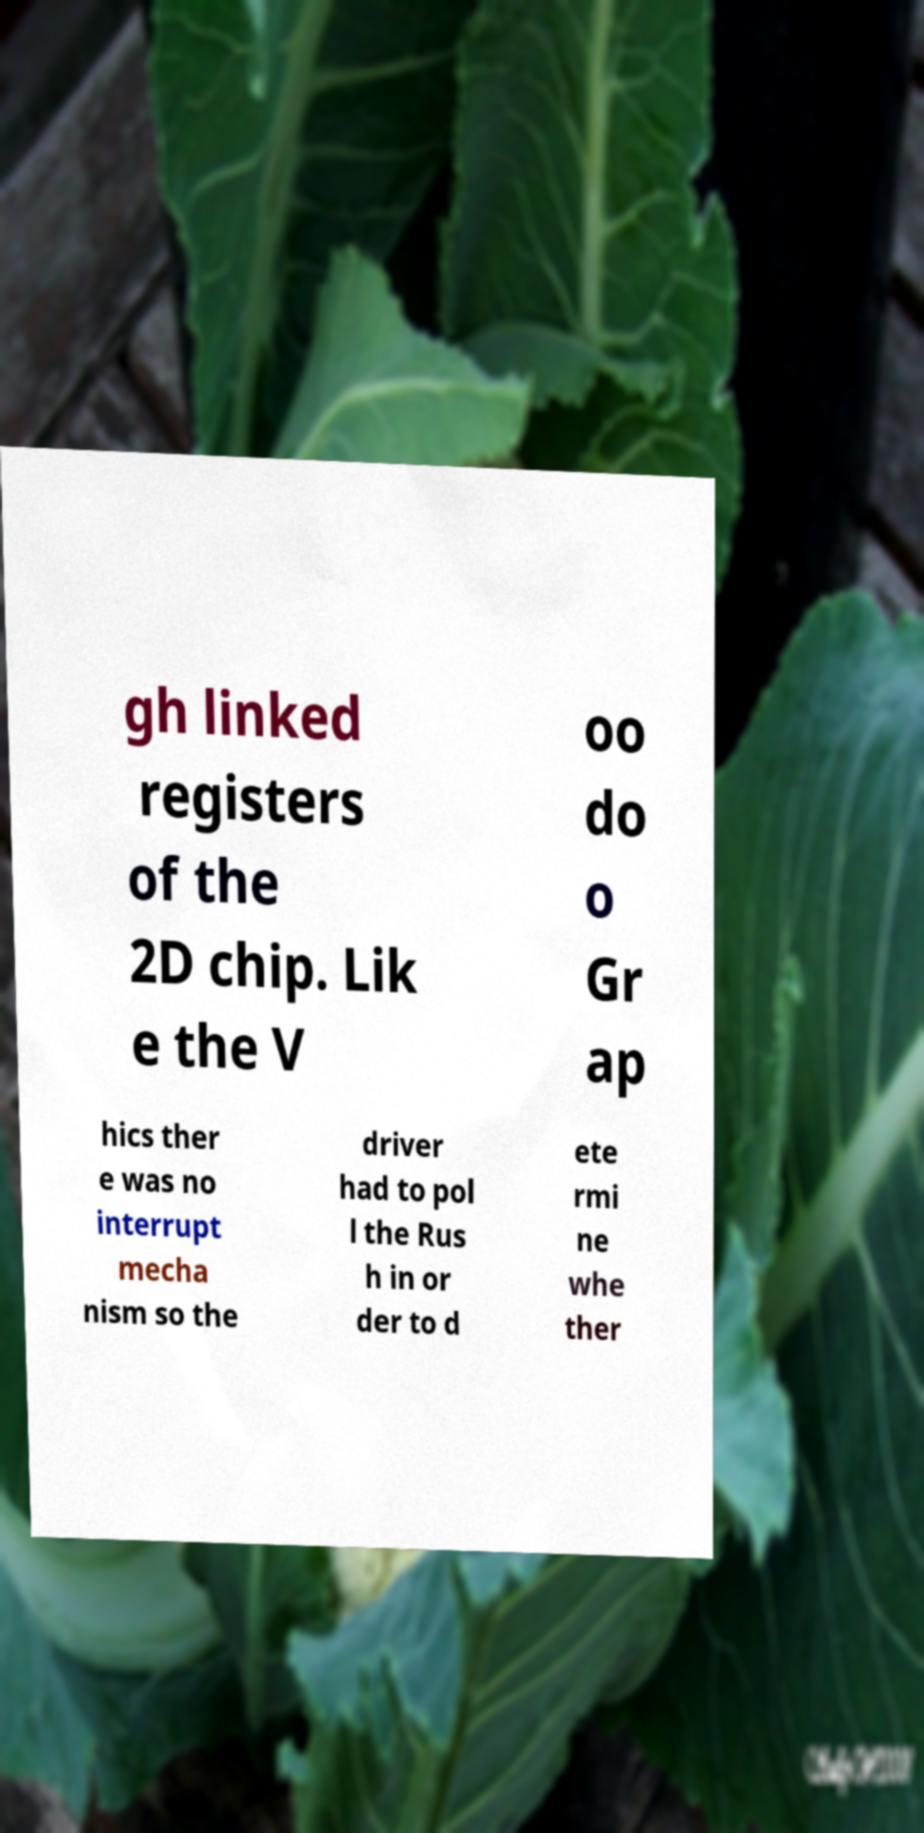Can you read and provide the text displayed in the image?This photo seems to have some interesting text. Can you extract and type it out for me? gh linked registers of the 2D chip. Lik e the V oo do o Gr ap hics ther e was no interrupt mecha nism so the driver had to pol l the Rus h in or der to d ete rmi ne whe ther 